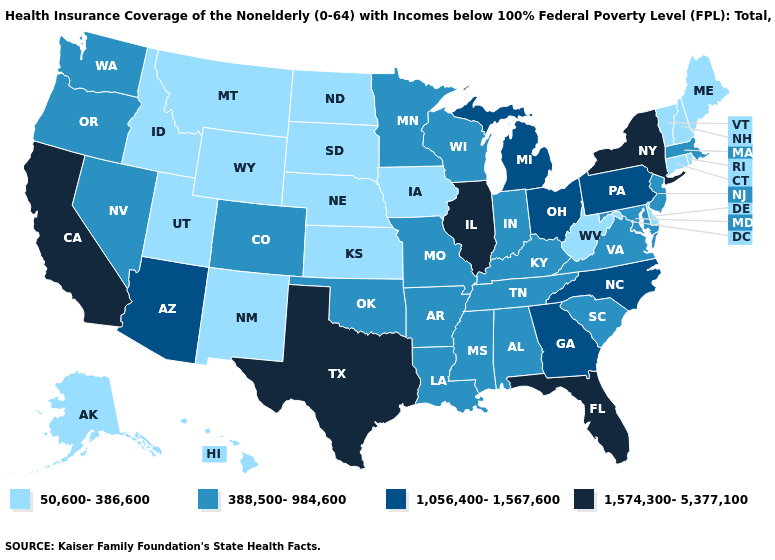Among the states that border New Jersey , does Delaware have the highest value?
Short answer required. No. Name the states that have a value in the range 1,574,300-5,377,100?
Short answer required. California, Florida, Illinois, New York, Texas. What is the value of Indiana?
Short answer required. 388,500-984,600. What is the value of Virginia?
Concise answer only. 388,500-984,600. What is the value of New Hampshire?
Give a very brief answer. 50,600-386,600. Among the states that border North Carolina , which have the lowest value?
Short answer required. South Carolina, Tennessee, Virginia. What is the value of Alabama?
Concise answer only. 388,500-984,600. Name the states that have a value in the range 1,056,400-1,567,600?
Keep it brief. Arizona, Georgia, Michigan, North Carolina, Ohio, Pennsylvania. Name the states that have a value in the range 388,500-984,600?
Concise answer only. Alabama, Arkansas, Colorado, Indiana, Kentucky, Louisiana, Maryland, Massachusetts, Minnesota, Mississippi, Missouri, Nevada, New Jersey, Oklahoma, Oregon, South Carolina, Tennessee, Virginia, Washington, Wisconsin. Does Missouri have the lowest value in the USA?
Keep it brief. No. Does Utah have the same value as Connecticut?
Be succinct. Yes. Name the states that have a value in the range 1,056,400-1,567,600?
Keep it brief. Arizona, Georgia, Michigan, North Carolina, Ohio, Pennsylvania. Does Texas have the lowest value in the USA?
Quick response, please. No. Name the states that have a value in the range 388,500-984,600?
Short answer required. Alabama, Arkansas, Colorado, Indiana, Kentucky, Louisiana, Maryland, Massachusetts, Minnesota, Mississippi, Missouri, Nevada, New Jersey, Oklahoma, Oregon, South Carolina, Tennessee, Virginia, Washington, Wisconsin. 